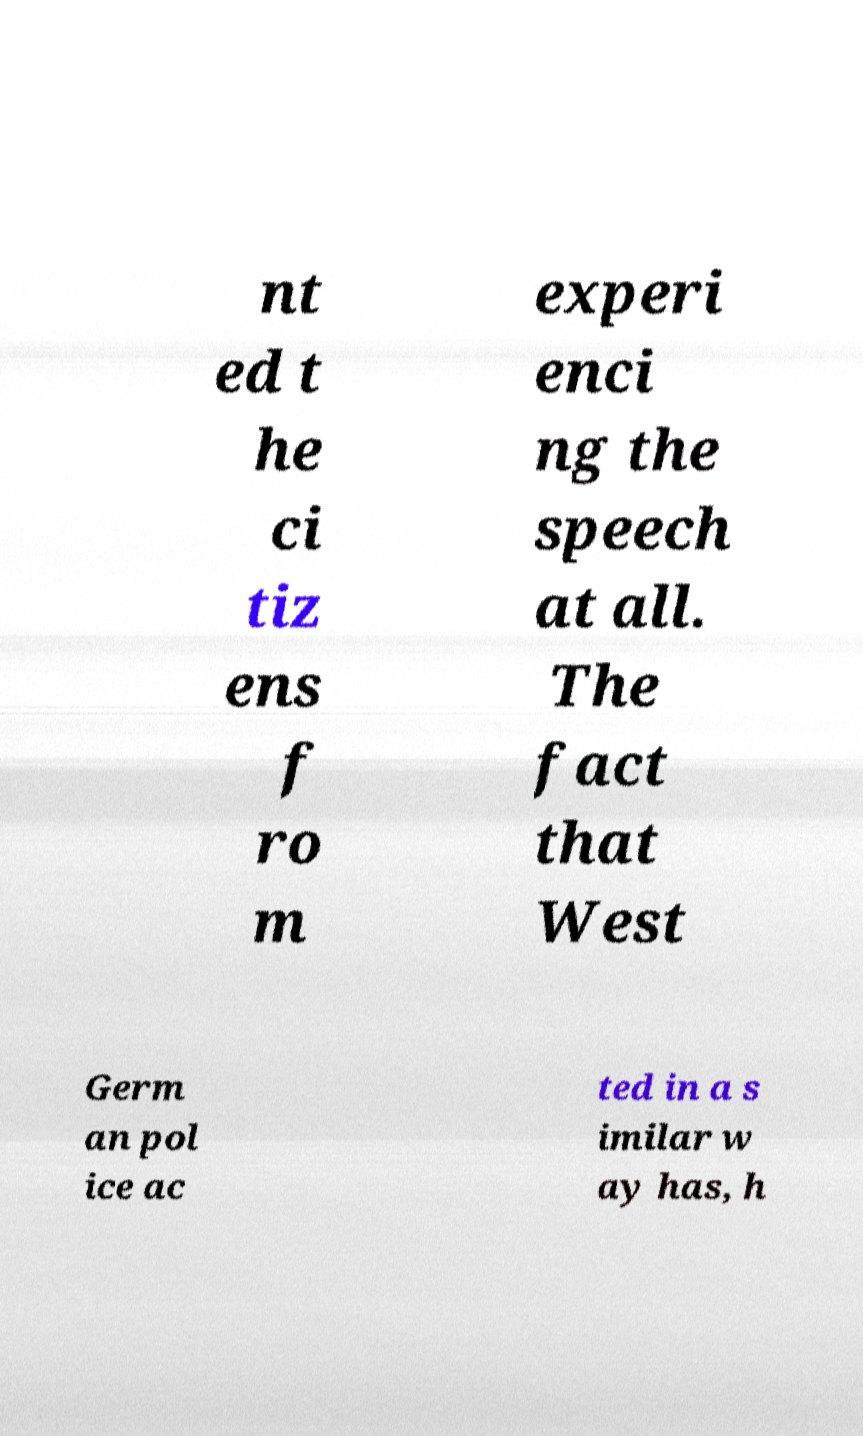For documentation purposes, I need the text within this image transcribed. Could you provide that? nt ed t he ci tiz ens f ro m experi enci ng the speech at all. The fact that West Germ an pol ice ac ted in a s imilar w ay has, h 